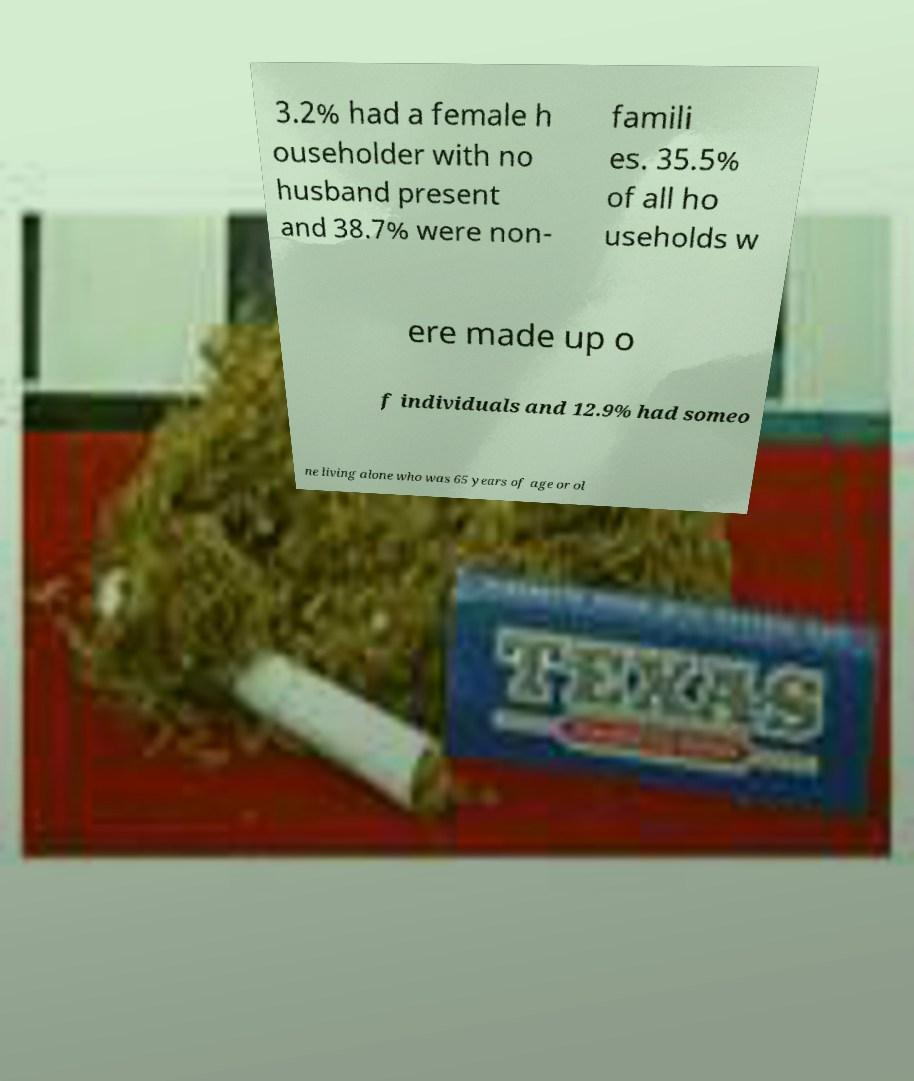Please identify and transcribe the text found in this image. 3.2% had a female h ouseholder with no husband present and 38.7% were non- famili es. 35.5% of all ho useholds w ere made up o f individuals and 12.9% had someo ne living alone who was 65 years of age or ol 